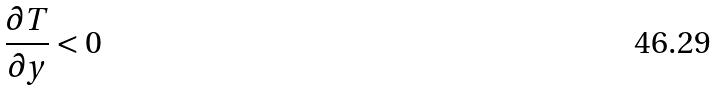Convert formula to latex. <formula><loc_0><loc_0><loc_500><loc_500>\frac { \partial T } { \partial y } < 0</formula> 